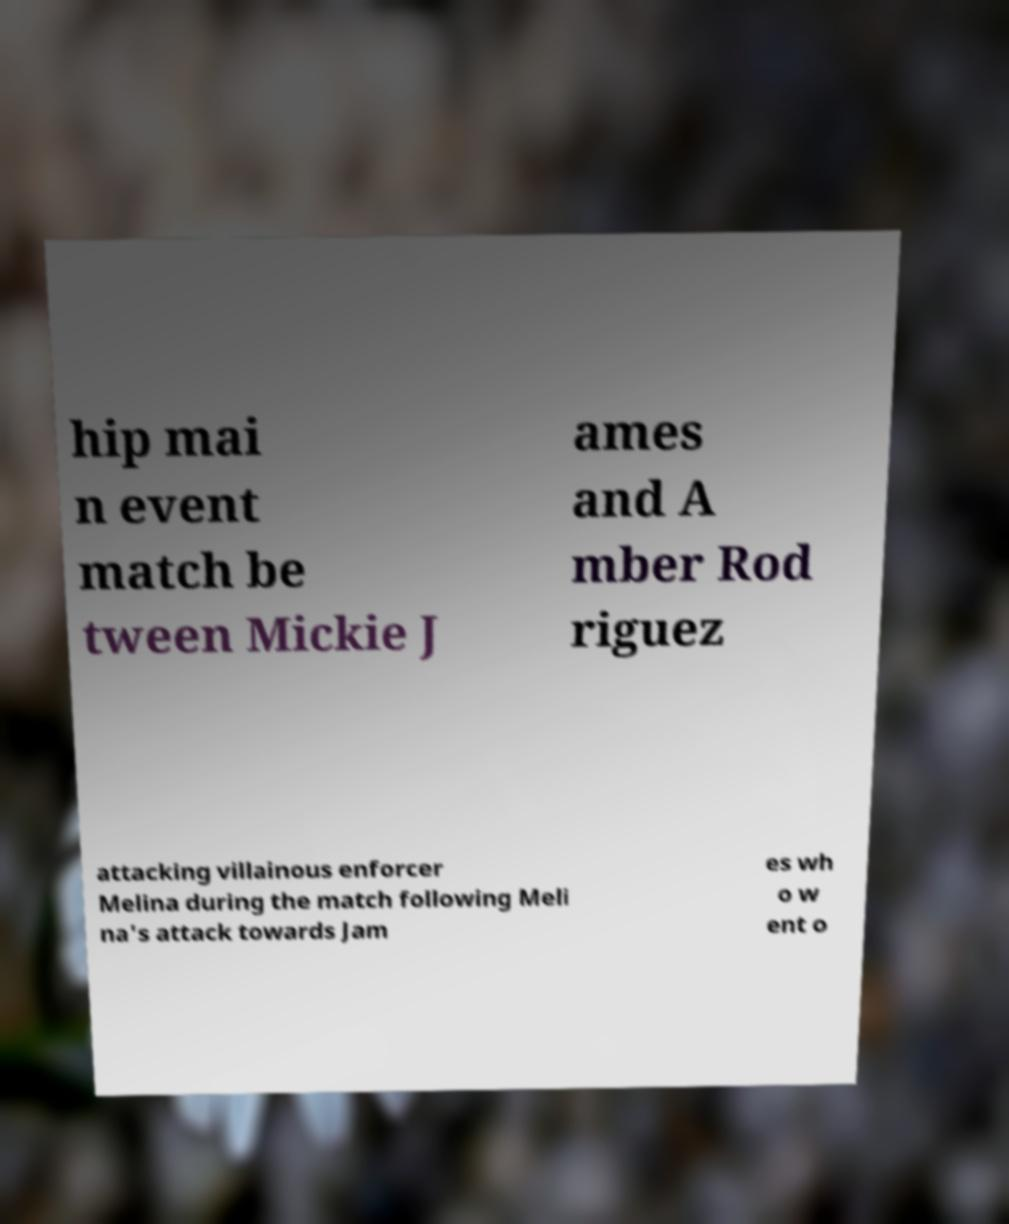Please identify and transcribe the text found in this image. hip mai n event match be tween Mickie J ames and A mber Rod riguez attacking villainous enforcer Melina during the match following Meli na's attack towards Jam es wh o w ent o 